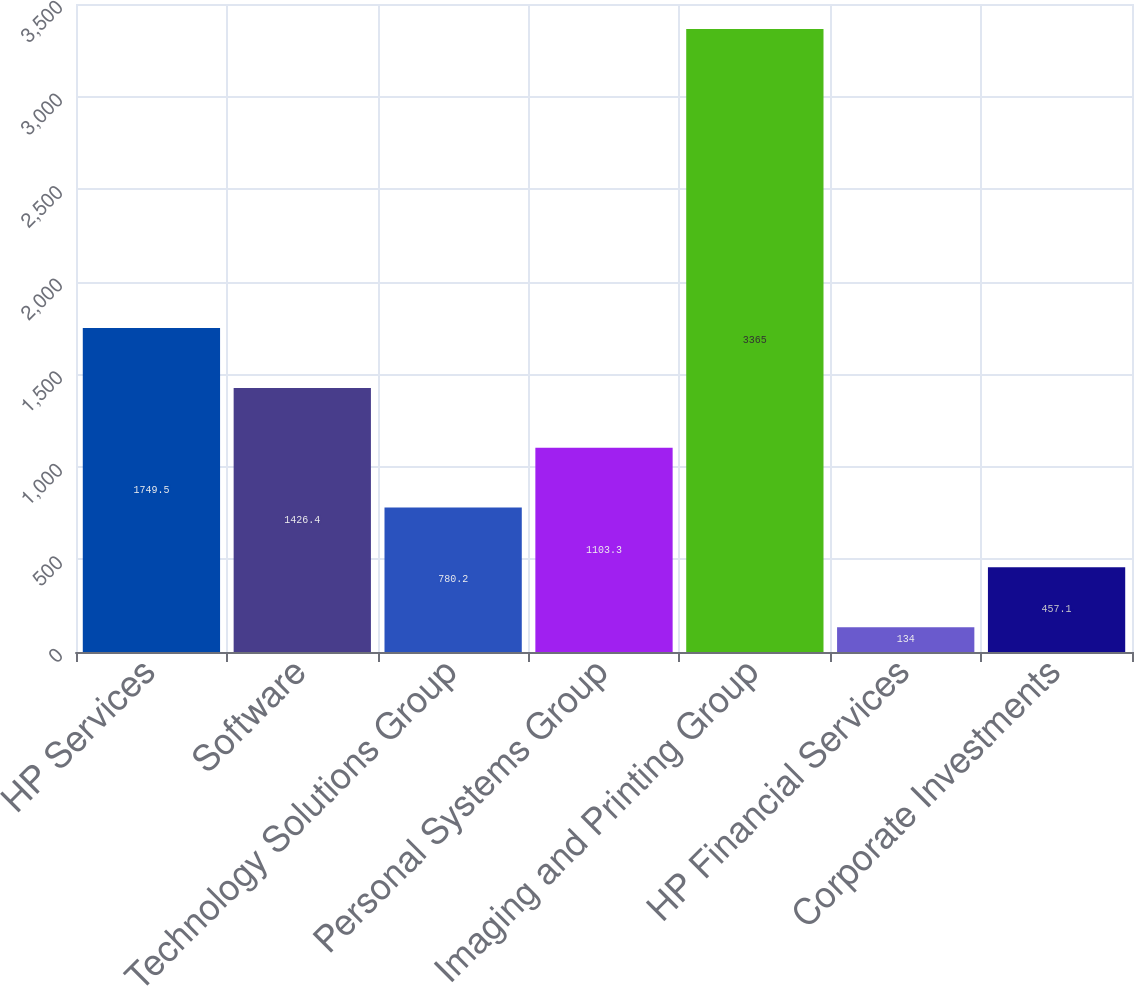<chart> <loc_0><loc_0><loc_500><loc_500><bar_chart><fcel>HP Services<fcel>Software<fcel>Technology Solutions Group<fcel>Personal Systems Group<fcel>Imaging and Printing Group<fcel>HP Financial Services<fcel>Corporate Investments<nl><fcel>1749.5<fcel>1426.4<fcel>780.2<fcel>1103.3<fcel>3365<fcel>134<fcel>457.1<nl></chart> 